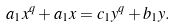<formula> <loc_0><loc_0><loc_500><loc_500>a _ { 1 } x ^ { q } + a _ { 1 } x = c _ { 1 } y ^ { q } + b _ { 1 } y .</formula> 